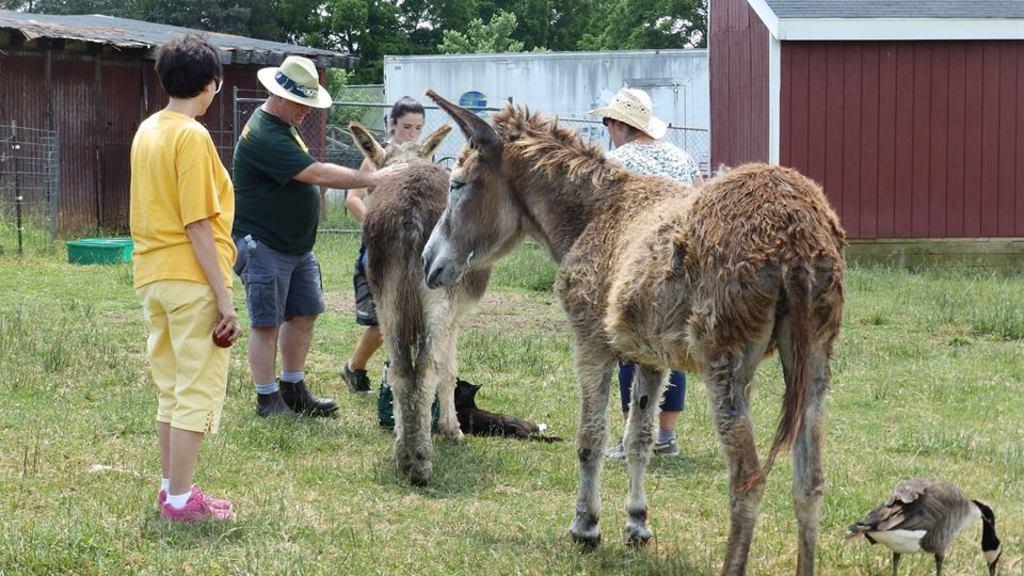Could you give a brief overview of what you see in this image? In this image I can see an open grass ground and on it I can see two donkeys, four persons, a bird and a black colour thing. I can also see two persons are wearing hats. In the background I can see a green colour thing, few shacks, the iron fences and number of trees. In the front I can see one person is holding a red colour thing. 